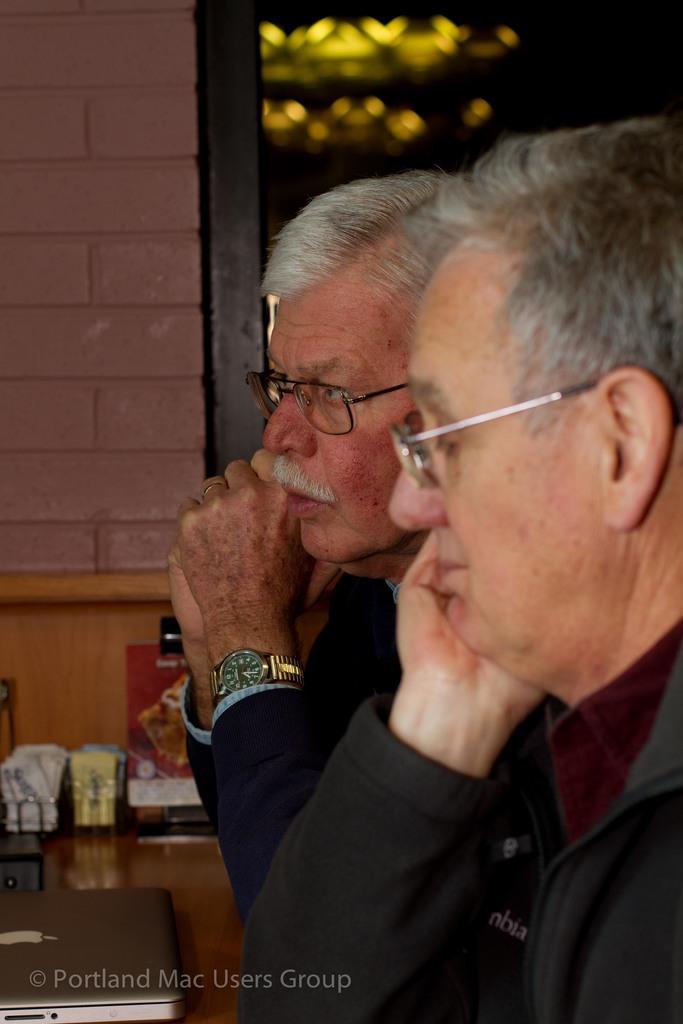Could you give a brief overview of what you see in this image? In this image I see 2 men and I see a watch on this man's hand and I see the watermark over here. In the background I see the wall and I see few things over here. 